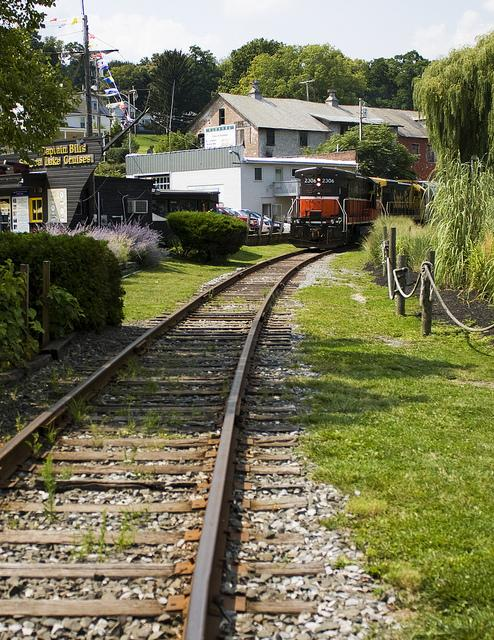What color is the lateral stripe around the train engine? Please explain your reasoning. red. The color is red. 